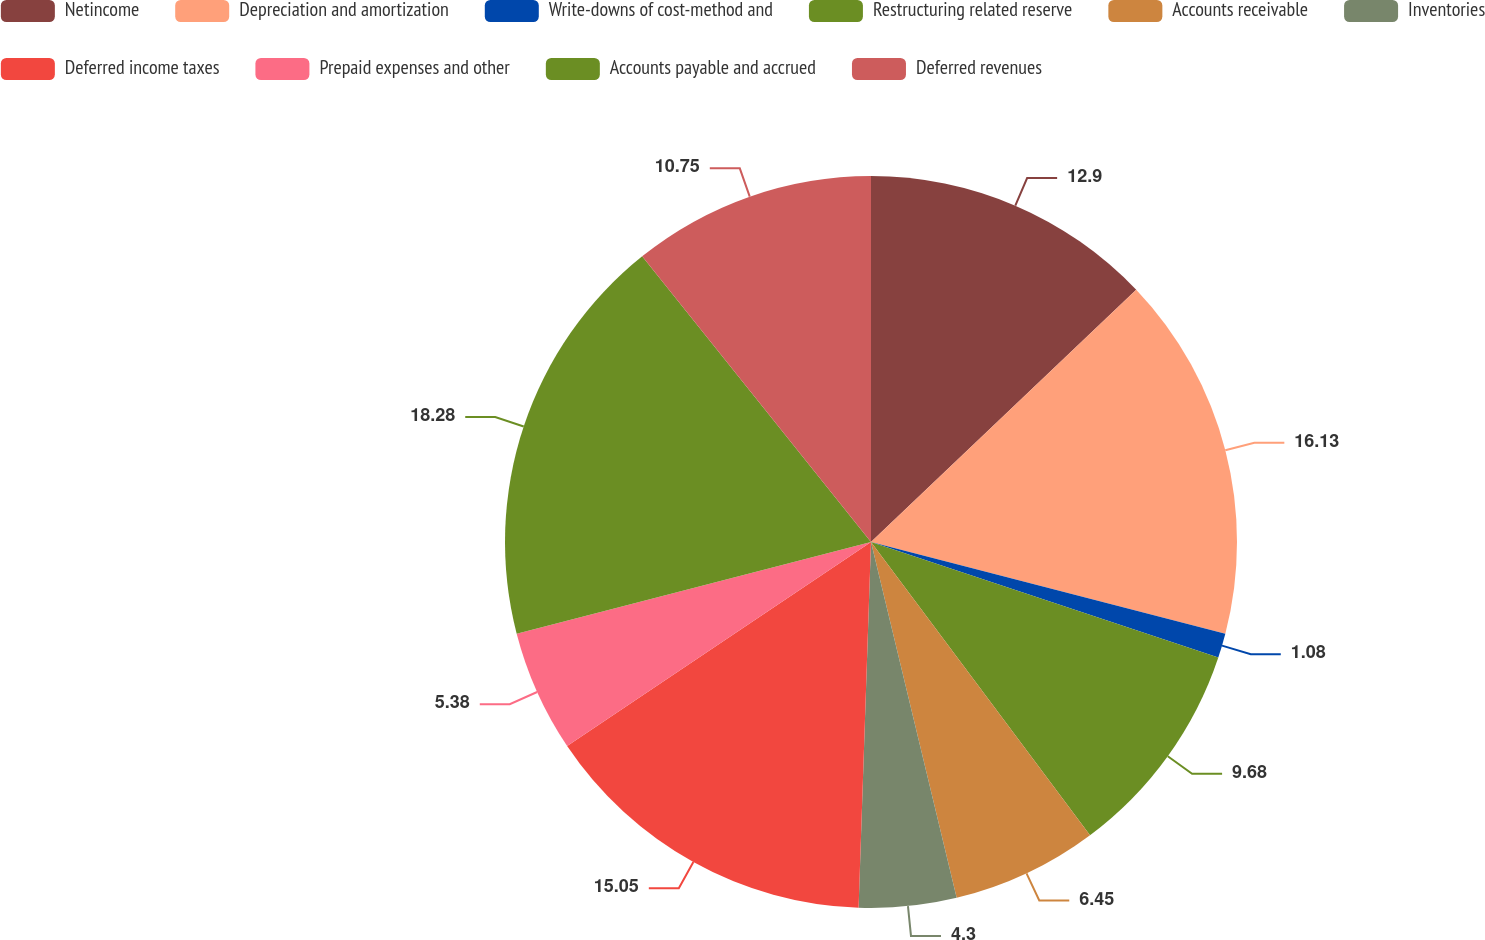<chart> <loc_0><loc_0><loc_500><loc_500><pie_chart><fcel>Netincome<fcel>Depreciation and amortization<fcel>Write-downs of cost-method and<fcel>Restructuring related reserve<fcel>Accounts receivable<fcel>Inventories<fcel>Deferred income taxes<fcel>Prepaid expenses and other<fcel>Accounts payable and accrued<fcel>Deferred revenues<nl><fcel>12.9%<fcel>16.13%<fcel>1.08%<fcel>9.68%<fcel>6.45%<fcel>4.3%<fcel>15.05%<fcel>5.38%<fcel>18.28%<fcel>10.75%<nl></chart> 